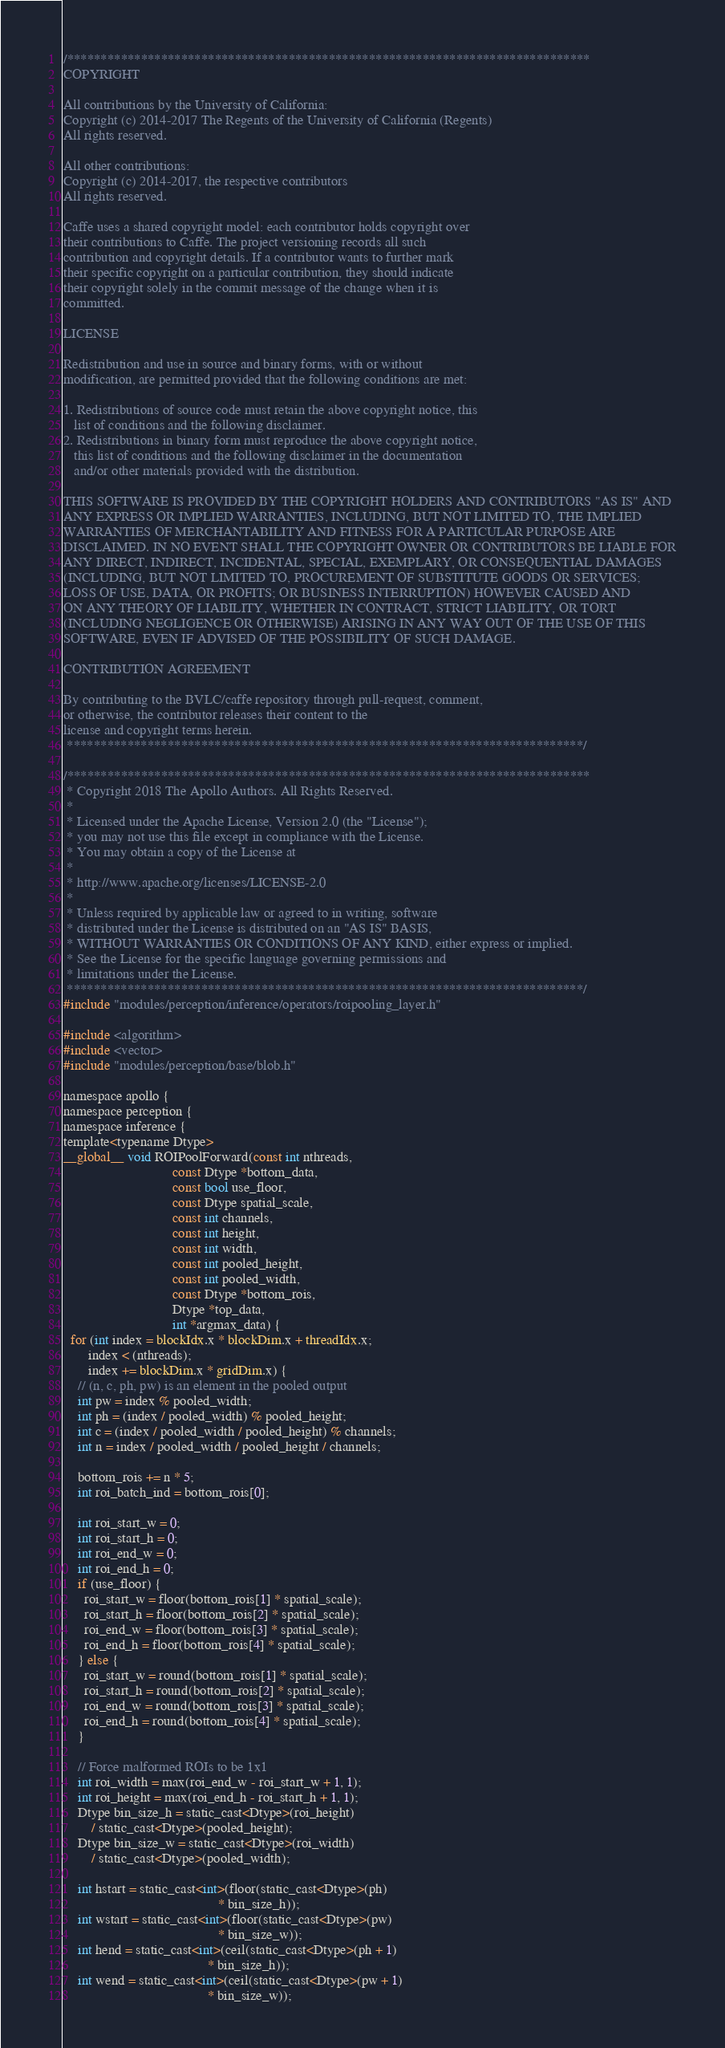Convert code to text. <code><loc_0><loc_0><loc_500><loc_500><_Cuda_>/******************************************************************************
COPYRIGHT

All contributions by the University of California:
Copyright (c) 2014-2017 The Regents of the University of California (Regents)
All rights reserved.

All other contributions:
Copyright (c) 2014-2017, the respective contributors
All rights reserved.

Caffe uses a shared copyright model: each contributor holds copyright over
their contributions to Caffe. The project versioning records all such
contribution and copyright details. If a contributor wants to further mark
their specific copyright on a particular contribution, they should indicate
their copyright solely in the commit message of the change when it is
committed.

LICENSE

Redistribution and use in source and binary forms, with or without
modification, are permitted provided that the following conditions are met: 

1. Redistributions of source code must retain the above copyright notice, this
   list of conditions and the following disclaimer. 
2. Redistributions in binary form must reproduce the above copyright notice,
   this list of conditions and the following disclaimer in the documentation
   and/or other materials provided with the distribution. 

THIS SOFTWARE IS PROVIDED BY THE COPYRIGHT HOLDERS AND CONTRIBUTORS "AS IS" AND
ANY EXPRESS OR IMPLIED WARRANTIES, INCLUDING, BUT NOT LIMITED TO, THE IMPLIED
WARRANTIES OF MERCHANTABILITY AND FITNESS FOR A PARTICULAR PURPOSE ARE
DISCLAIMED. IN NO EVENT SHALL THE COPYRIGHT OWNER OR CONTRIBUTORS BE LIABLE FOR
ANY DIRECT, INDIRECT, INCIDENTAL, SPECIAL, EXEMPLARY, OR CONSEQUENTIAL DAMAGES
(INCLUDING, BUT NOT LIMITED TO, PROCUREMENT OF SUBSTITUTE GOODS OR SERVICES;
LOSS OF USE, DATA, OR PROFITS; OR BUSINESS INTERRUPTION) HOWEVER CAUSED AND
ON ANY THEORY OF LIABILITY, WHETHER IN CONTRACT, STRICT LIABILITY, OR TORT
(INCLUDING NEGLIGENCE OR OTHERWISE) ARISING IN ANY WAY OUT OF THE USE OF THIS
SOFTWARE, EVEN IF ADVISED OF THE POSSIBILITY OF SUCH DAMAGE.

CONTRIBUTION AGREEMENT

By contributing to the BVLC/caffe repository through pull-request, comment,
or otherwise, the contributor releases their content to the
license and copyright terms herein.
 *****************************************************************************/

/******************************************************************************
 * Copyright 2018 The Apollo Authors. All Rights Reserved.
 *
 * Licensed under the Apache License, Version 2.0 (the "License");
 * you may not use this file except in compliance with the License.
 * You may obtain a copy of the License at
 *
 * http://www.apache.org/licenses/LICENSE-2.0
 *
 * Unless required by applicable law or agreed to in writing, software
 * distributed under the License is distributed on an "AS IS" BASIS,
 * WITHOUT WARRANTIES OR CONDITIONS OF ANY KIND, either express or implied.
 * See the License for the specific language governing permissions and
 * limitations under the License.
 *****************************************************************************/
#include "modules/perception/inference/operators/roipooling_layer.h"

#include <algorithm>
#include <vector>
#include "modules/perception/base/blob.h"

namespace apollo {
namespace perception {
namespace inference {
template<typename Dtype>
__global__ void ROIPoolForward(const int nthreads,
                               const Dtype *bottom_data,
                               const bool use_floor,
                               const Dtype spatial_scale,
                               const int channels,
                               const int height,
                               const int width,
                               const int pooled_height,
                               const int pooled_width,
                               const Dtype *bottom_rois,
                               Dtype *top_data,
                               int *argmax_data) {
  for (int index = blockIdx.x * blockDim.x + threadIdx.x;
       index < (nthreads);
       index += blockDim.x * gridDim.x) {
    // (n, c, ph, pw) is an element in the pooled output
    int pw = index % pooled_width;
    int ph = (index / pooled_width) % pooled_height;
    int c = (index / pooled_width / pooled_height) % channels;
    int n = index / pooled_width / pooled_height / channels;

    bottom_rois += n * 5;
    int roi_batch_ind = bottom_rois[0];

    int roi_start_w = 0;
    int roi_start_h = 0;
    int roi_end_w = 0;
    int roi_end_h = 0;
    if (use_floor) {
      roi_start_w = floor(bottom_rois[1] * spatial_scale);
      roi_start_h = floor(bottom_rois[2] * spatial_scale);
      roi_end_w = floor(bottom_rois[3] * spatial_scale);
      roi_end_h = floor(bottom_rois[4] * spatial_scale);
    } else {
      roi_start_w = round(bottom_rois[1] * spatial_scale);
      roi_start_h = round(bottom_rois[2] * spatial_scale);
      roi_end_w = round(bottom_rois[3] * spatial_scale);
      roi_end_h = round(bottom_rois[4] * spatial_scale);
    }

    // Force malformed ROIs to be 1x1
    int roi_width = max(roi_end_w - roi_start_w + 1, 1);
    int roi_height = max(roi_end_h - roi_start_h + 1, 1);
    Dtype bin_size_h = static_cast<Dtype>(roi_height)
        / static_cast<Dtype>(pooled_height);
    Dtype bin_size_w = static_cast<Dtype>(roi_width)
        / static_cast<Dtype>(pooled_width);

    int hstart = static_cast<int>(floor(static_cast<Dtype>(ph)
                                            * bin_size_h));
    int wstart = static_cast<int>(floor(static_cast<Dtype>(pw)
                                            * bin_size_w));
    int hend = static_cast<int>(ceil(static_cast<Dtype>(ph + 1)
                                         * bin_size_h));
    int wend = static_cast<int>(ceil(static_cast<Dtype>(pw + 1)
                                         * bin_size_w));
</code> 